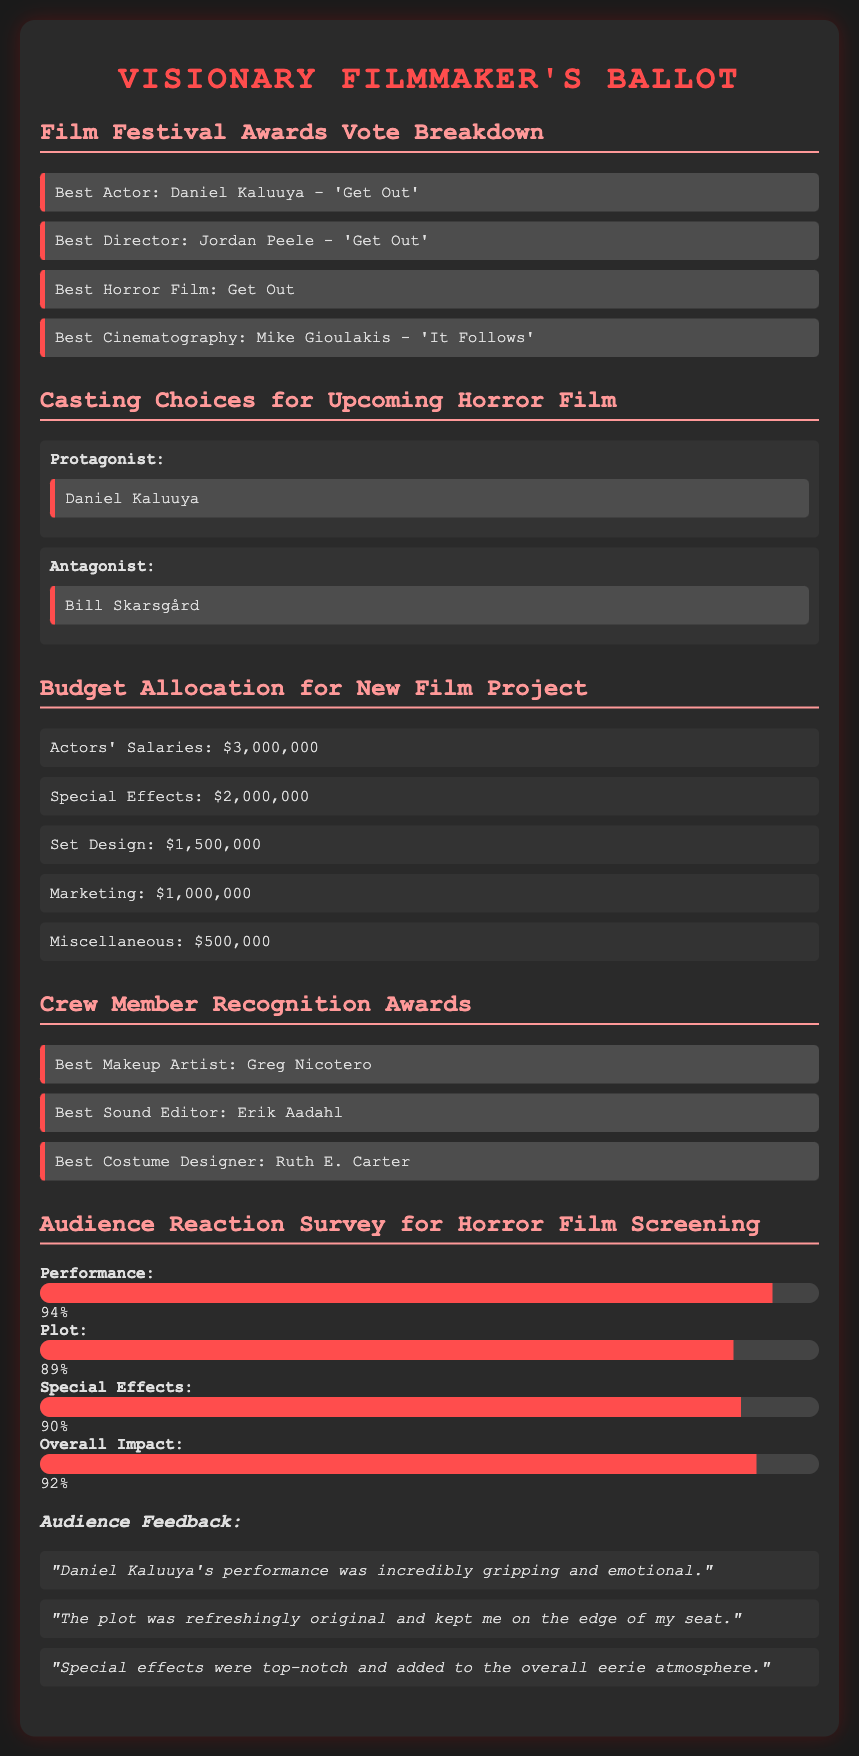What is the title of the best horror film? The title of the best horror film listed in the document is shown under the Film Festival Awards section.
Answer: Get Out Who won Best Actor? The winner of Best Actor can be found in the Film Festival Awards section of the ballot.
Answer: Daniel Kaluuya What percentage was awarded for Special Effects? The percentage for Special Effects is displayed in the Audience Reaction Survey section and represents audience feedback.
Answer: 90% Who is cast as the Protagonist? The casting choices for the Protagonist can be found in the Casting Choices section of the document.
Answer: Daniel Kaluuya How much is allocated for Actors' Salaries? The budget item for Actors' Salaries is stated in the Budget Allocation section.
Answer: $3,000,000 Which crew member won Best Makeup Artist? The winner of Best Makeup Artist is detailed in the Crew Member Recognition Awards section.
Answer: Greg Nicotero What rating did the film receive for Overall Impact? The rating for Overall Impact can be found in the Audience Reaction Survey and reflects audience appreciation.
Answer: 92% Who was selected as the Antagonist? The selection for the Antagonist role is listed in the Casting Choices section of the document.
Answer: Bill Skarsgård What is the total budget allocated for Special Effects? The budget for Special Effects is specified in the Budget Allocation section.
Answer: $2,000,000 